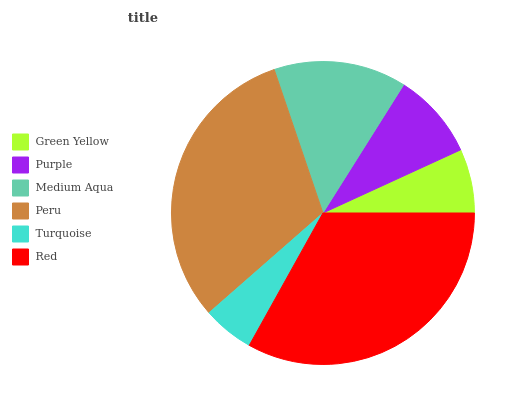Is Turquoise the minimum?
Answer yes or no. Yes. Is Red the maximum?
Answer yes or no. Yes. Is Purple the minimum?
Answer yes or no. No. Is Purple the maximum?
Answer yes or no. No. Is Purple greater than Green Yellow?
Answer yes or no. Yes. Is Green Yellow less than Purple?
Answer yes or no. Yes. Is Green Yellow greater than Purple?
Answer yes or no. No. Is Purple less than Green Yellow?
Answer yes or no. No. Is Medium Aqua the high median?
Answer yes or no. Yes. Is Purple the low median?
Answer yes or no. Yes. Is Peru the high median?
Answer yes or no. No. Is Green Yellow the low median?
Answer yes or no. No. 